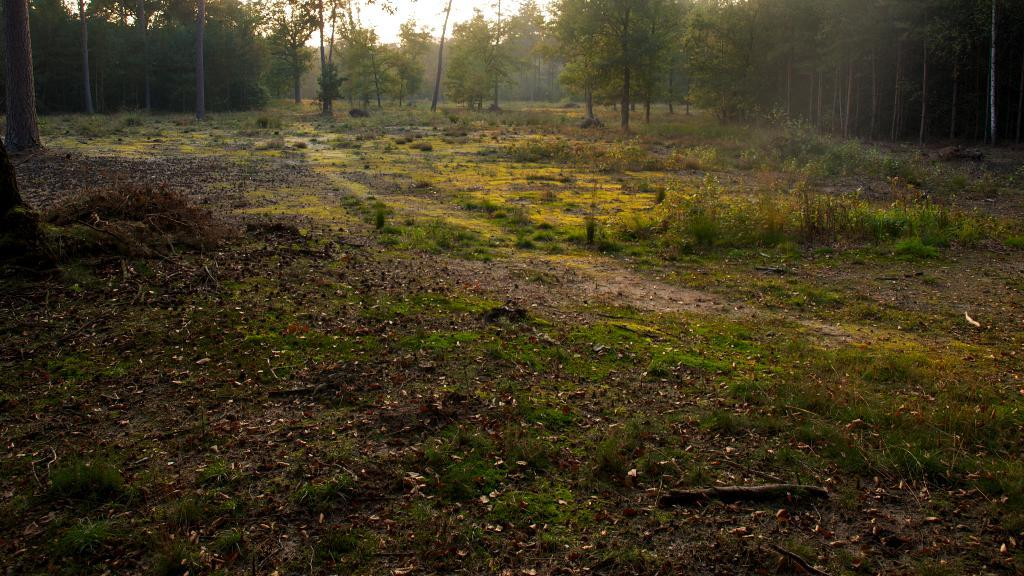What type of vegetation can be seen in the image? There are trees in the image. What else can be seen on the ground in the image? There is grass in the image. What is visible in the background of the image? The sky is visible in the image. What type of government is depicted in the image? There is no depiction of a government in the image; it features trees, grass, and the sky. What activity is taking place in the image? There is no specific activity taking place in the image; it simply shows trees, grass, and the sky. 